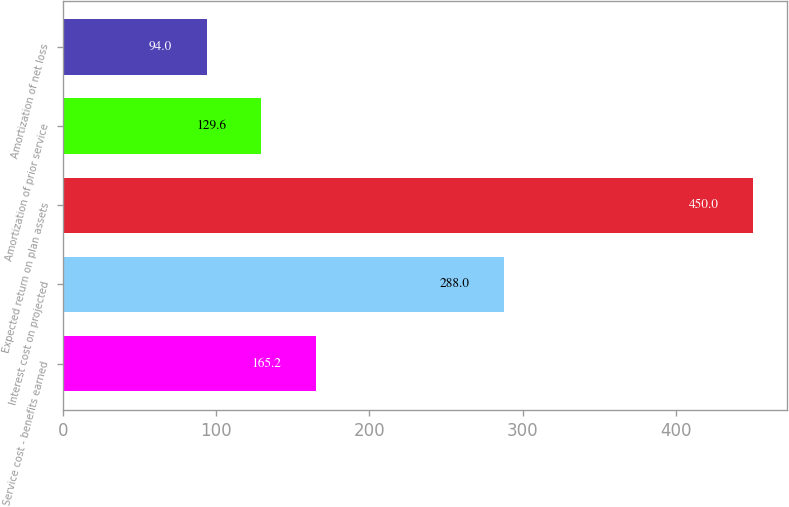Convert chart. <chart><loc_0><loc_0><loc_500><loc_500><bar_chart><fcel>Service cost - benefits earned<fcel>Interest cost on projected<fcel>Expected return on plan assets<fcel>Amortization of prior service<fcel>Amortization of net loss<nl><fcel>165.2<fcel>288<fcel>450<fcel>129.6<fcel>94<nl></chart> 